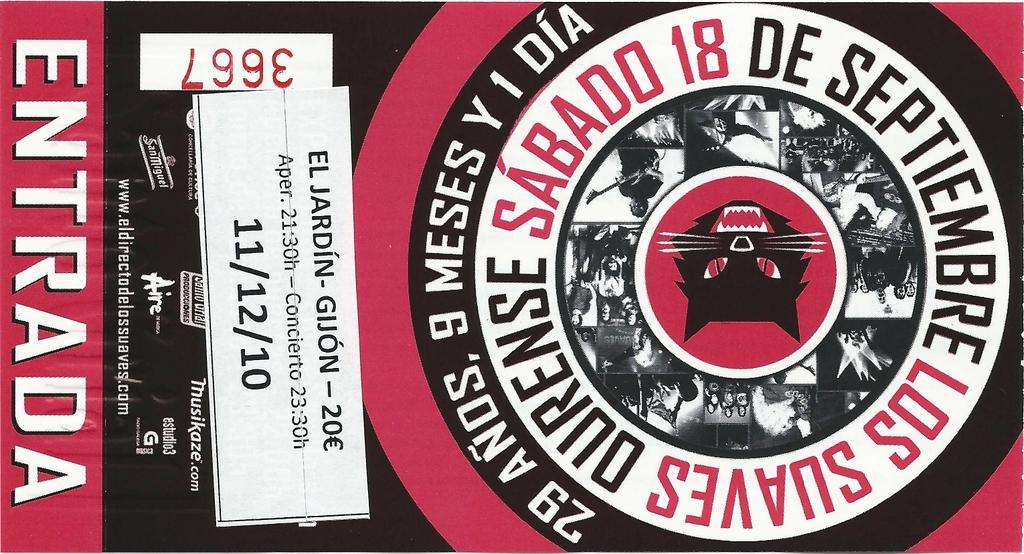<image>
Give a short and clear explanation of the subsequent image. the cover of something that says 'entrada' at the bottom of the page 